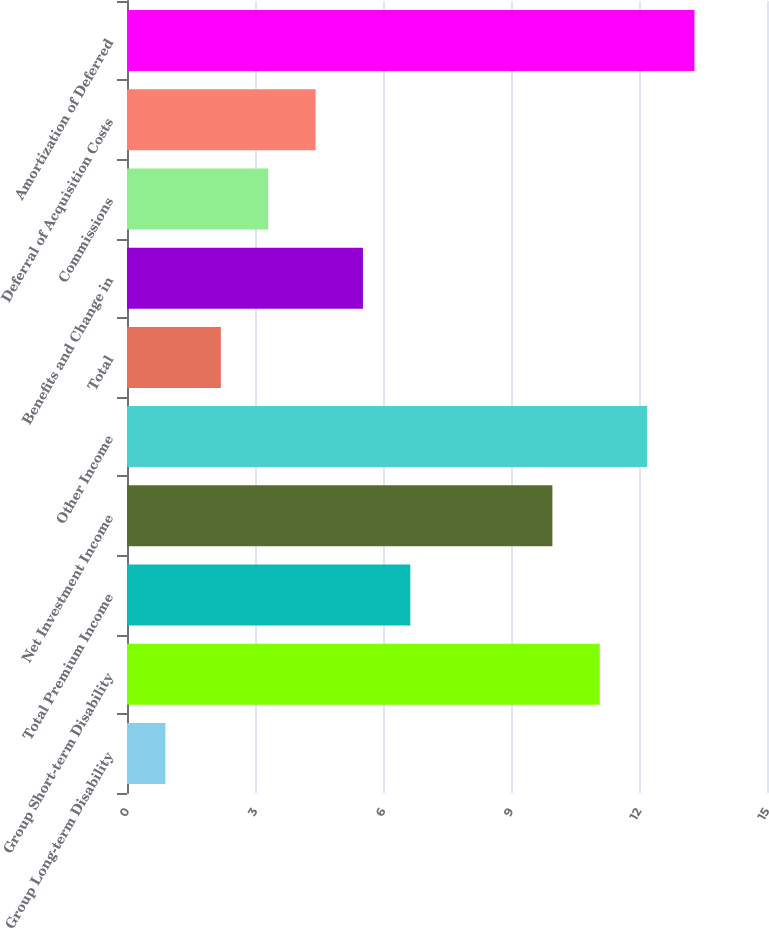Convert chart. <chart><loc_0><loc_0><loc_500><loc_500><bar_chart><fcel>Group Long-term Disability<fcel>Group Short-term Disability<fcel>Total Premium Income<fcel>Net Investment Income<fcel>Other Income<fcel>Total<fcel>Benefits and Change in<fcel>Commissions<fcel>Deferral of Acquisition Costs<fcel>Amortization of Deferred<nl><fcel>0.9<fcel>11.08<fcel>6.64<fcel>9.97<fcel>12.19<fcel>2.2<fcel>5.53<fcel>3.31<fcel>4.42<fcel>13.3<nl></chart> 